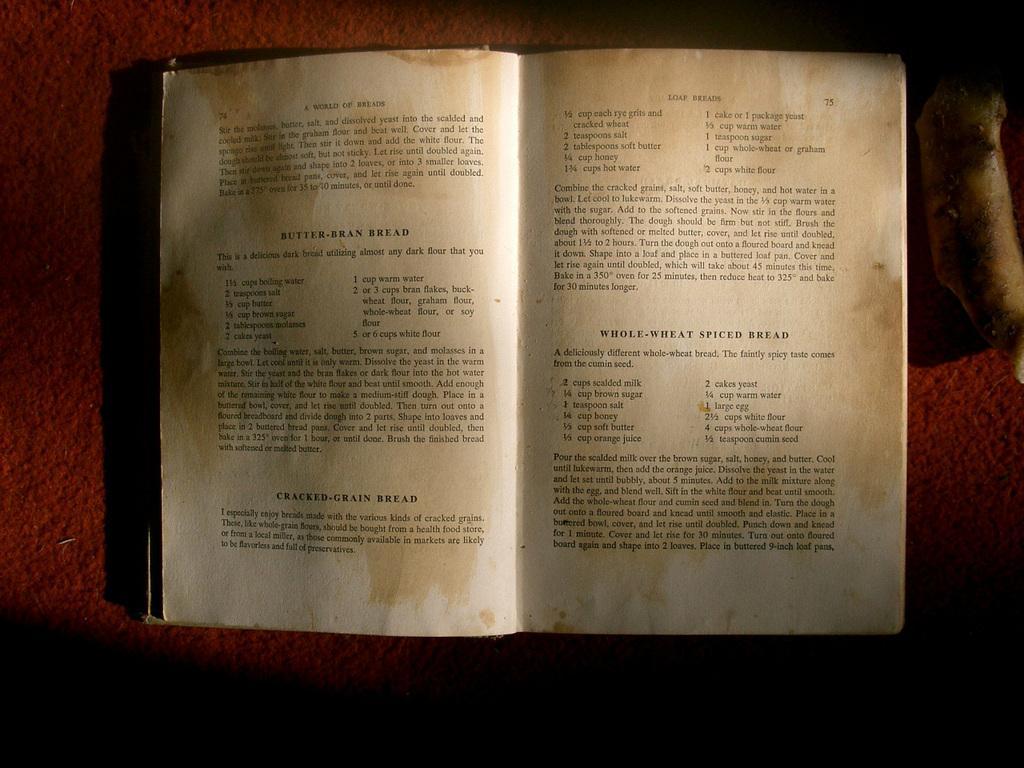Describe this image in one or two sentences. In this image there is an open book with some text on it. 